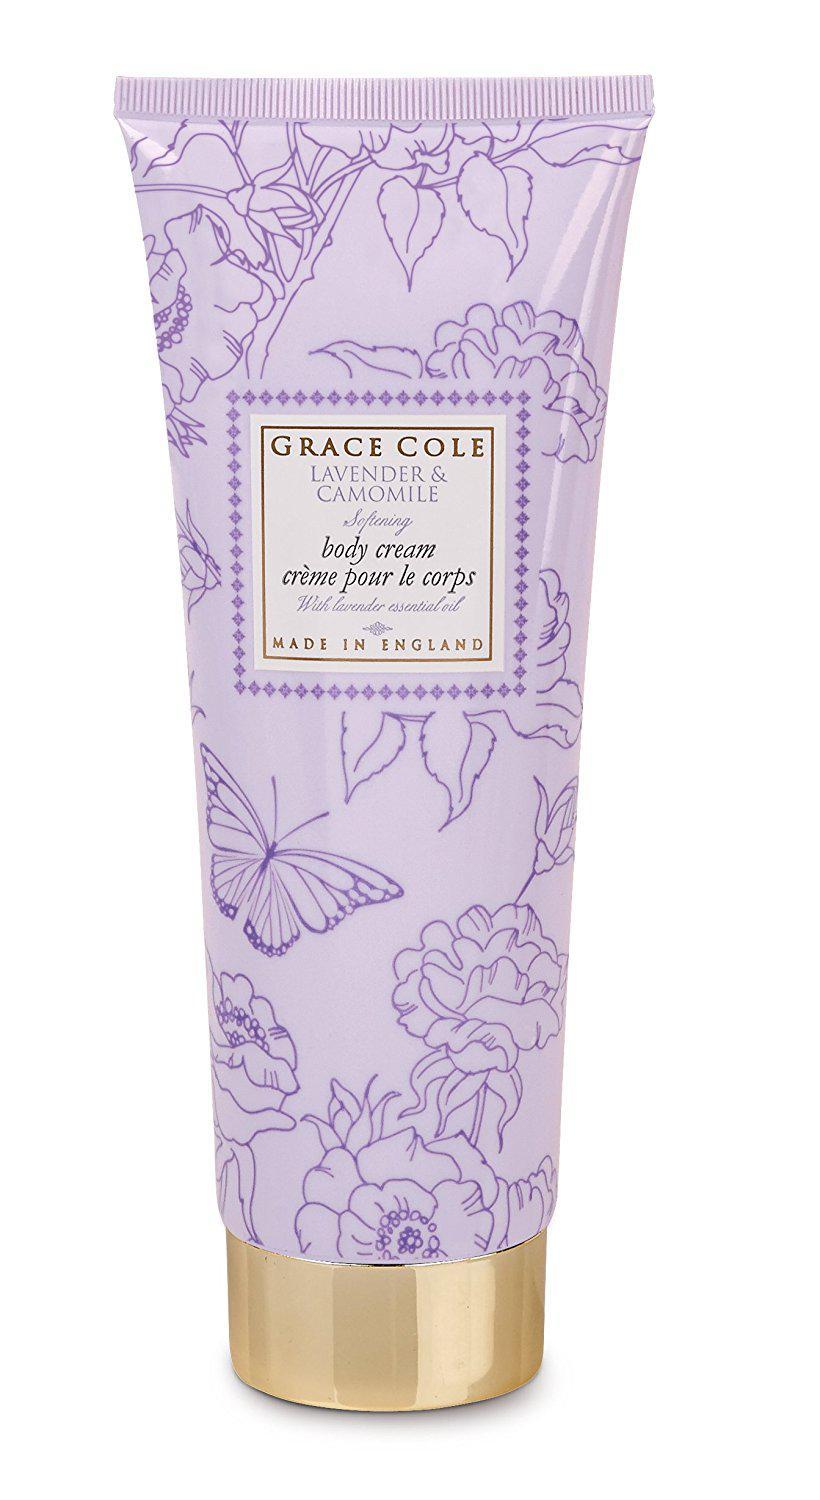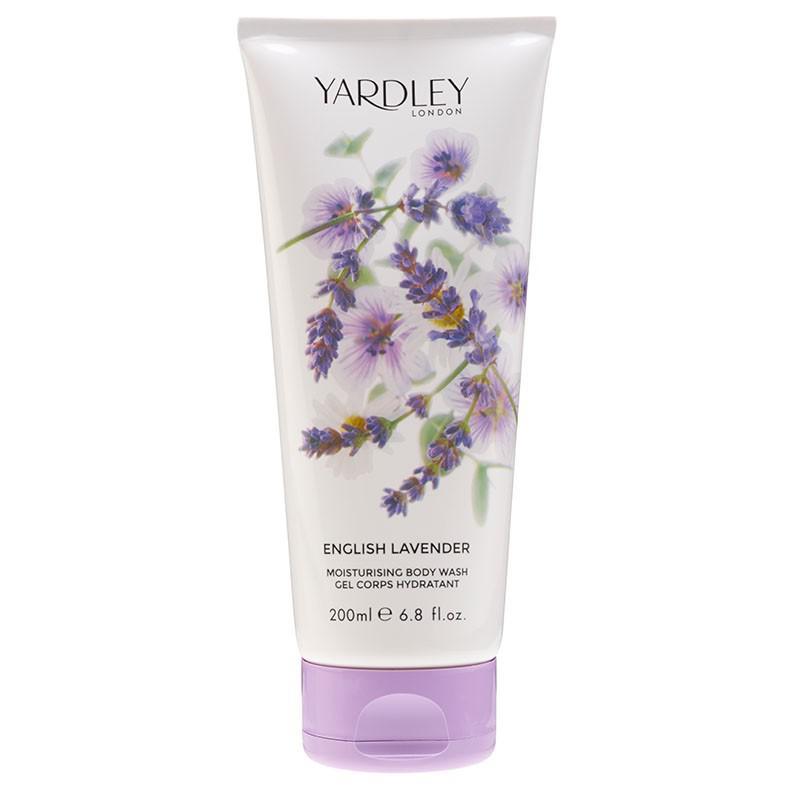The first image is the image on the left, the second image is the image on the right. For the images shown, is this caption "The right image shows a single product, which is decorated with lavender flowers, and left and right images show products in the same shape and applicator formats." true? Answer yes or no. Yes. The first image is the image on the left, the second image is the image on the right. Analyze the images presented: Is the assertion "Two containers of body wash have their cap on the bottom." valid? Answer yes or no. Yes. 